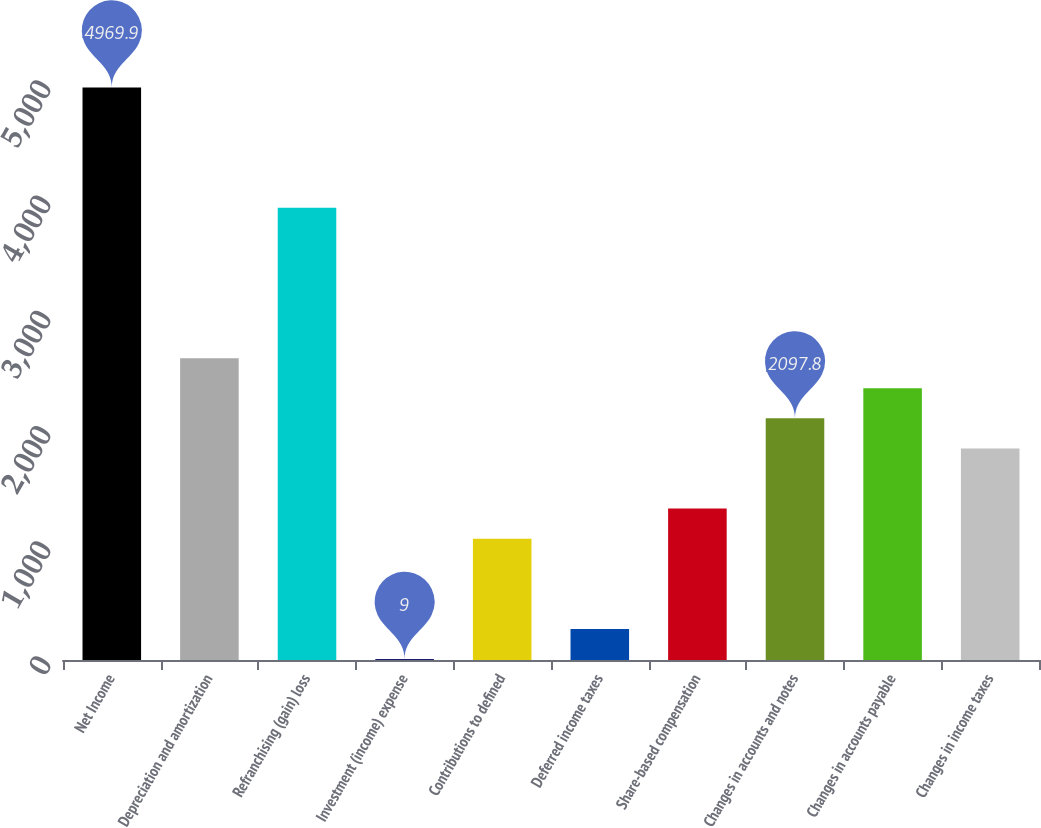Convert chart to OTSL. <chart><loc_0><loc_0><loc_500><loc_500><bar_chart><fcel>Net Income<fcel>Depreciation and amortization<fcel>Refranchising (gain) loss<fcel>Investment (income) expense<fcel>Contributions to defined<fcel>Deferred income taxes<fcel>Share-based compensation<fcel>Changes in accounts and notes<fcel>Changes in accounts payable<fcel>Changes in income taxes<nl><fcel>4969.9<fcel>2620<fcel>3925.5<fcel>9<fcel>1053.4<fcel>270.1<fcel>1314.5<fcel>2097.8<fcel>2358.9<fcel>1836.7<nl></chart> 